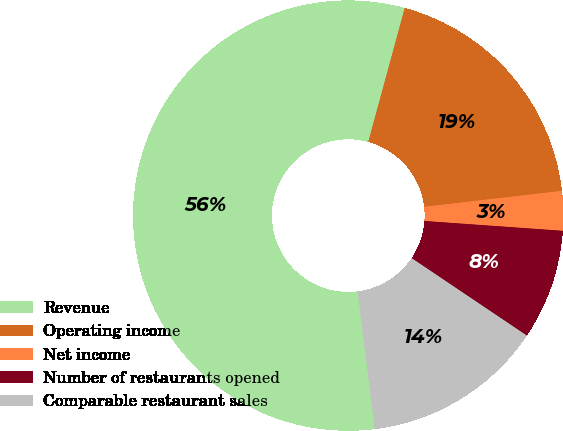<chart> <loc_0><loc_0><loc_500><loc_500><pie_chart><fcel>Revenue<fcel>Operating income<fcel>Net income<fcel>Number of restaurants opened<fcel>Comparable restaurant sales<nl><fcel>56.2%<fcel>18.94%<fcel>2.96%<fcel>8.29%<fcel>13.61%<nl></chart> 